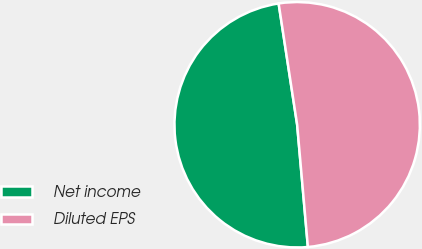Convert chart to OTSL. <chart><loc_0><loc_0><loc_500><loc_500><pie_chart><fcel>Net income<fcel>Diluted EPS<nl><fcel>48.98%<fcel>51.02%<nl></chart> 